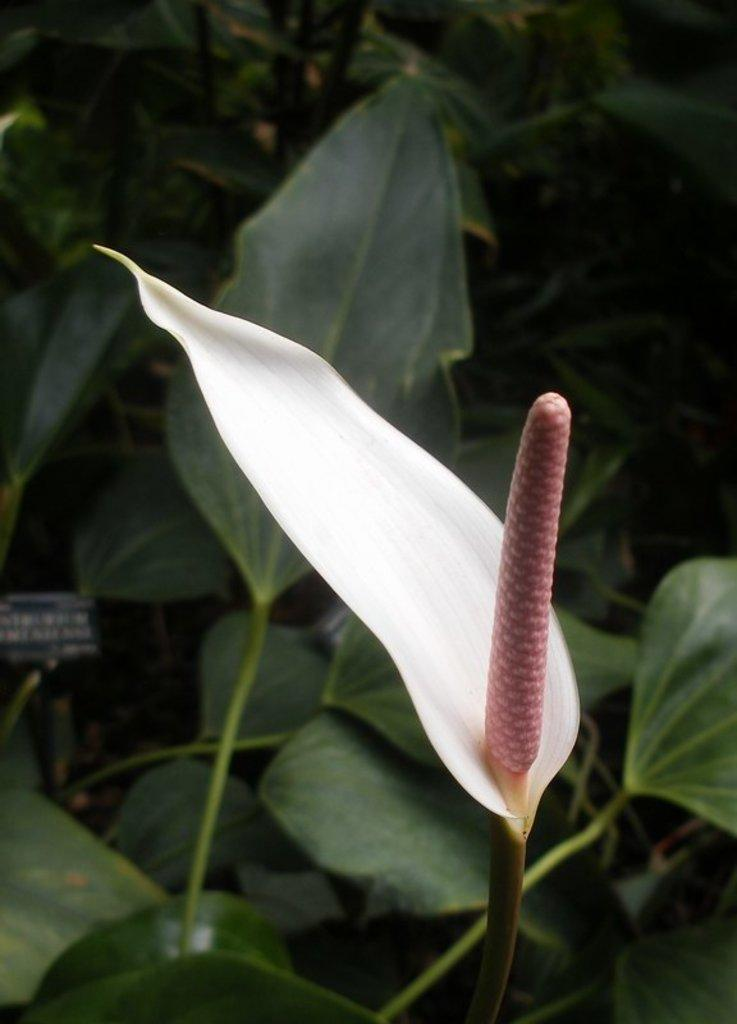What is the main subject in the center of the image? There is a flower in the center of the image. Can you describe the colors of the flower? The flower has white and pink colors. What can be seen in the background of the image? There is a banner and plants in the background of the image, along with a few other objects. What type of juice is being served at the harbor in the image? There is no juice or harbor present in the image; it features a flower with a banner and plants in the background. Can you tell me the title of the record being played in the background of the image? There is no record or music being played in the image; it only shows a flower, a banner, and plants in the background. 